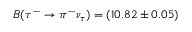Convert formula to latex. <formula><loc_0><loc_0><loc_500><loc_500>B ( \tau ^ { - } \to \pi ^ { - } \nu _ { \tau } ) = ( 1 0 . 8 2 \pm 0 . 0 5 ) \</formula> 